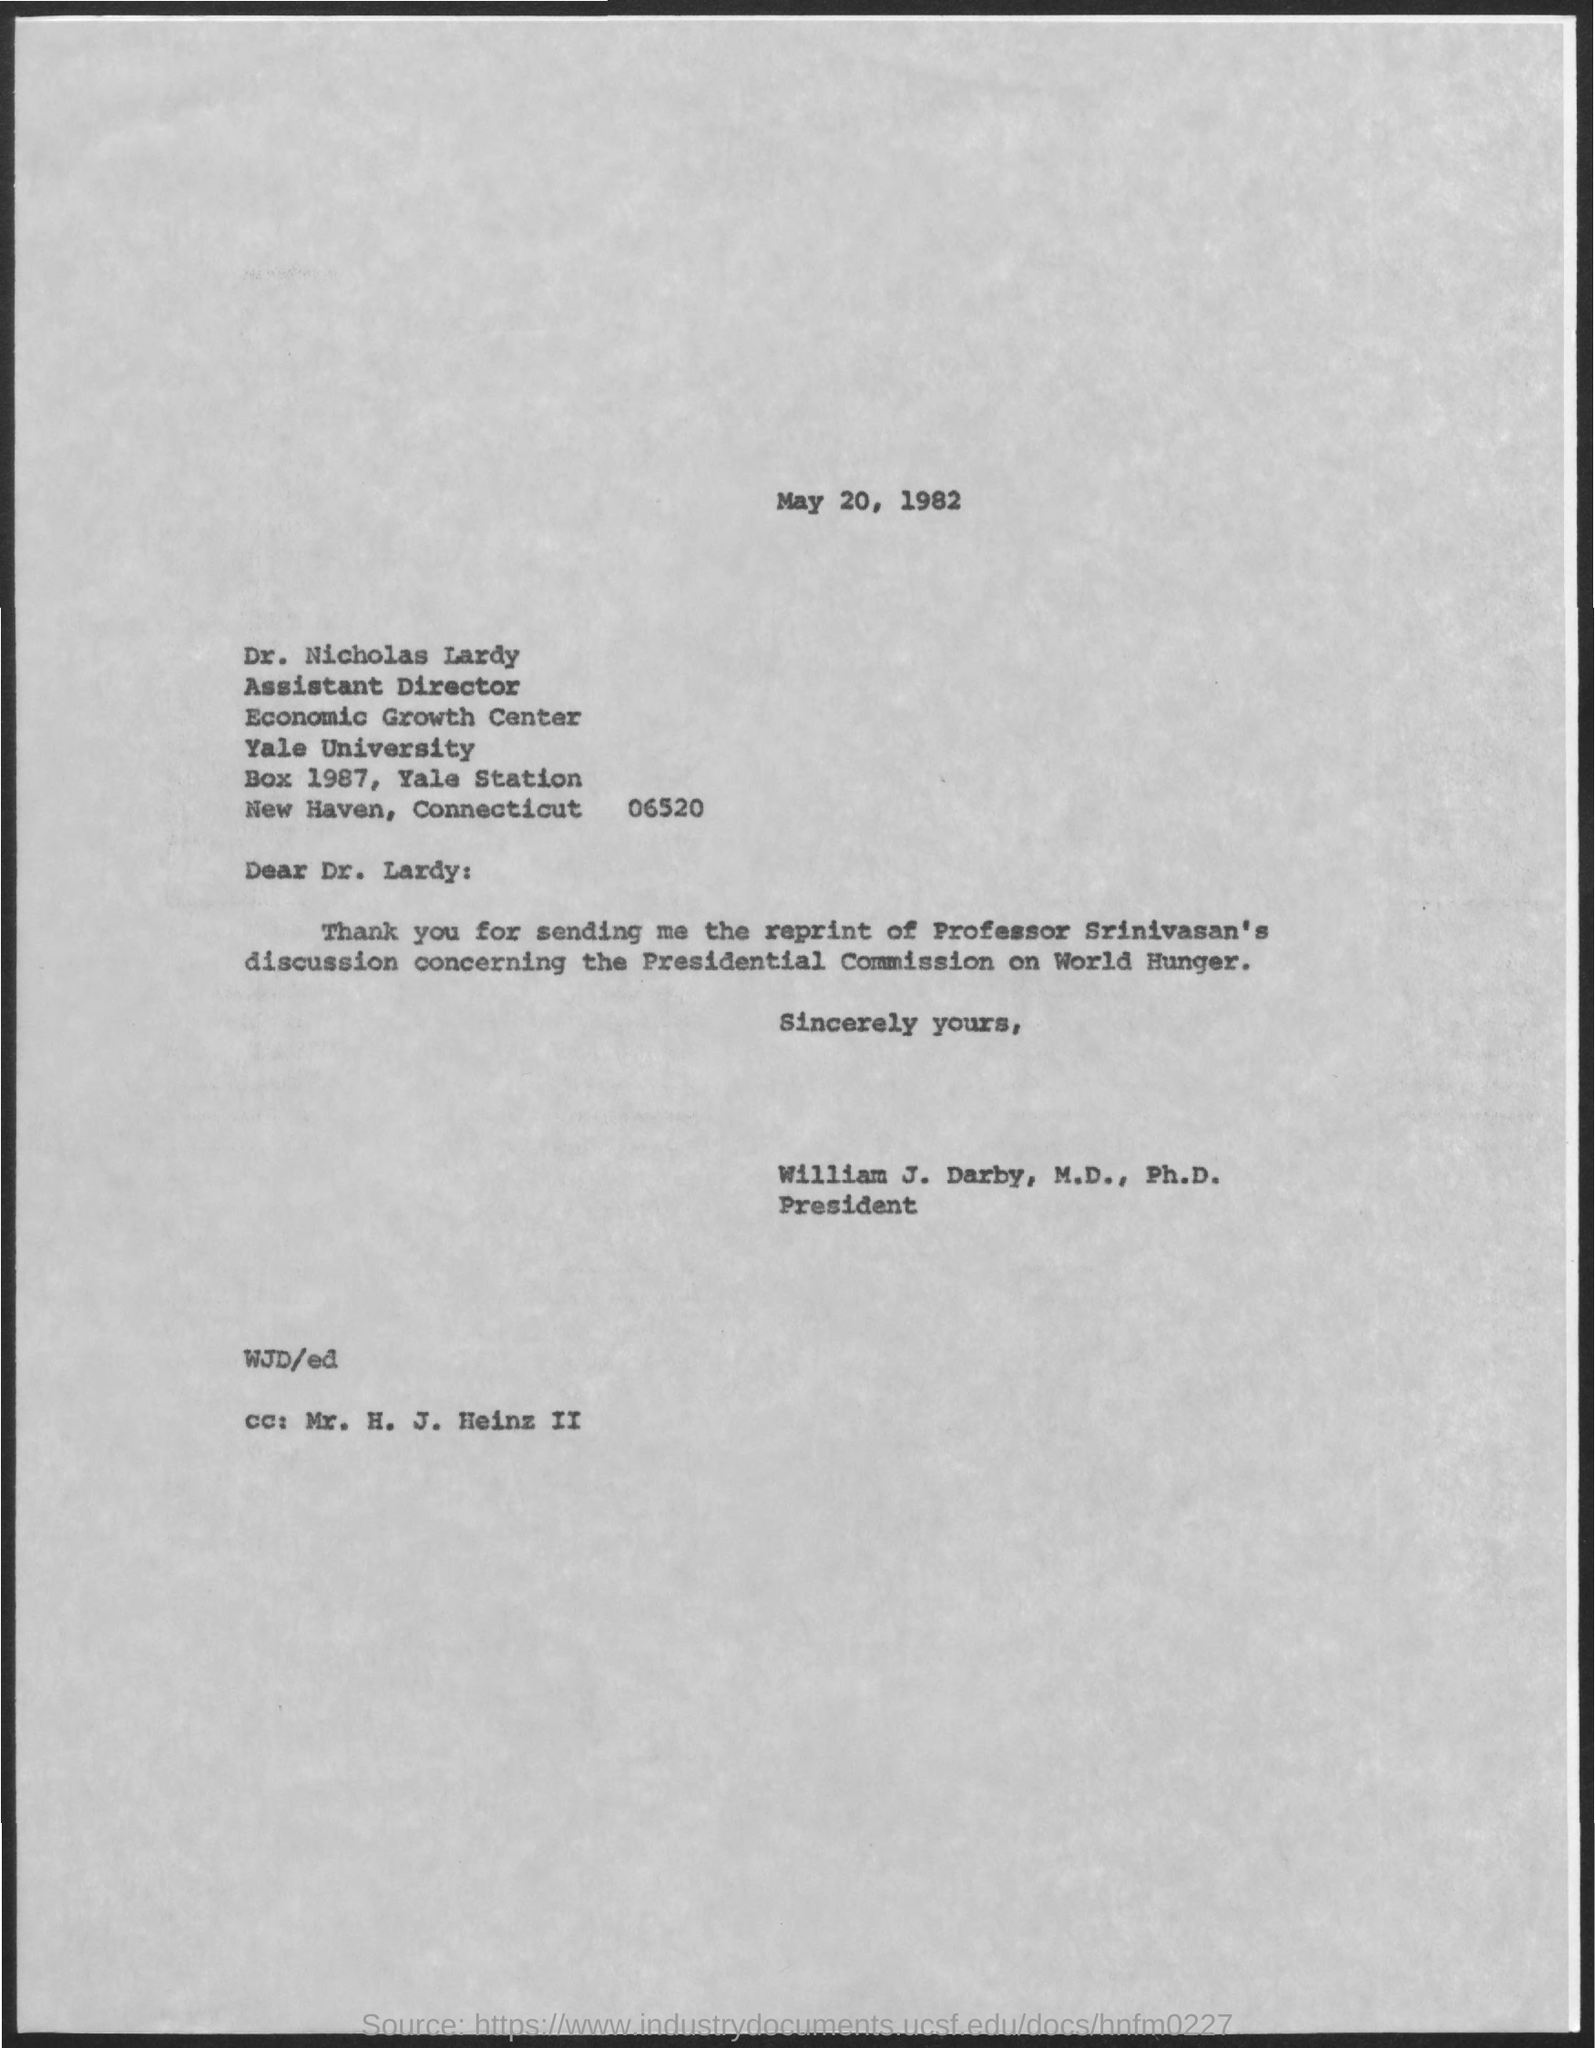List a handful of essential elements in this visual. The presidential commission on world hunger is the subject of discussion. The person addressed in the email cc field as 'h. j. Heinz ii.' is unknown. Dr. Lardy sent a reprint of Professor Srinivasan's discussion. The document in question is dated May 20, 1982. The letter is addressed to Dr. Lardy. 